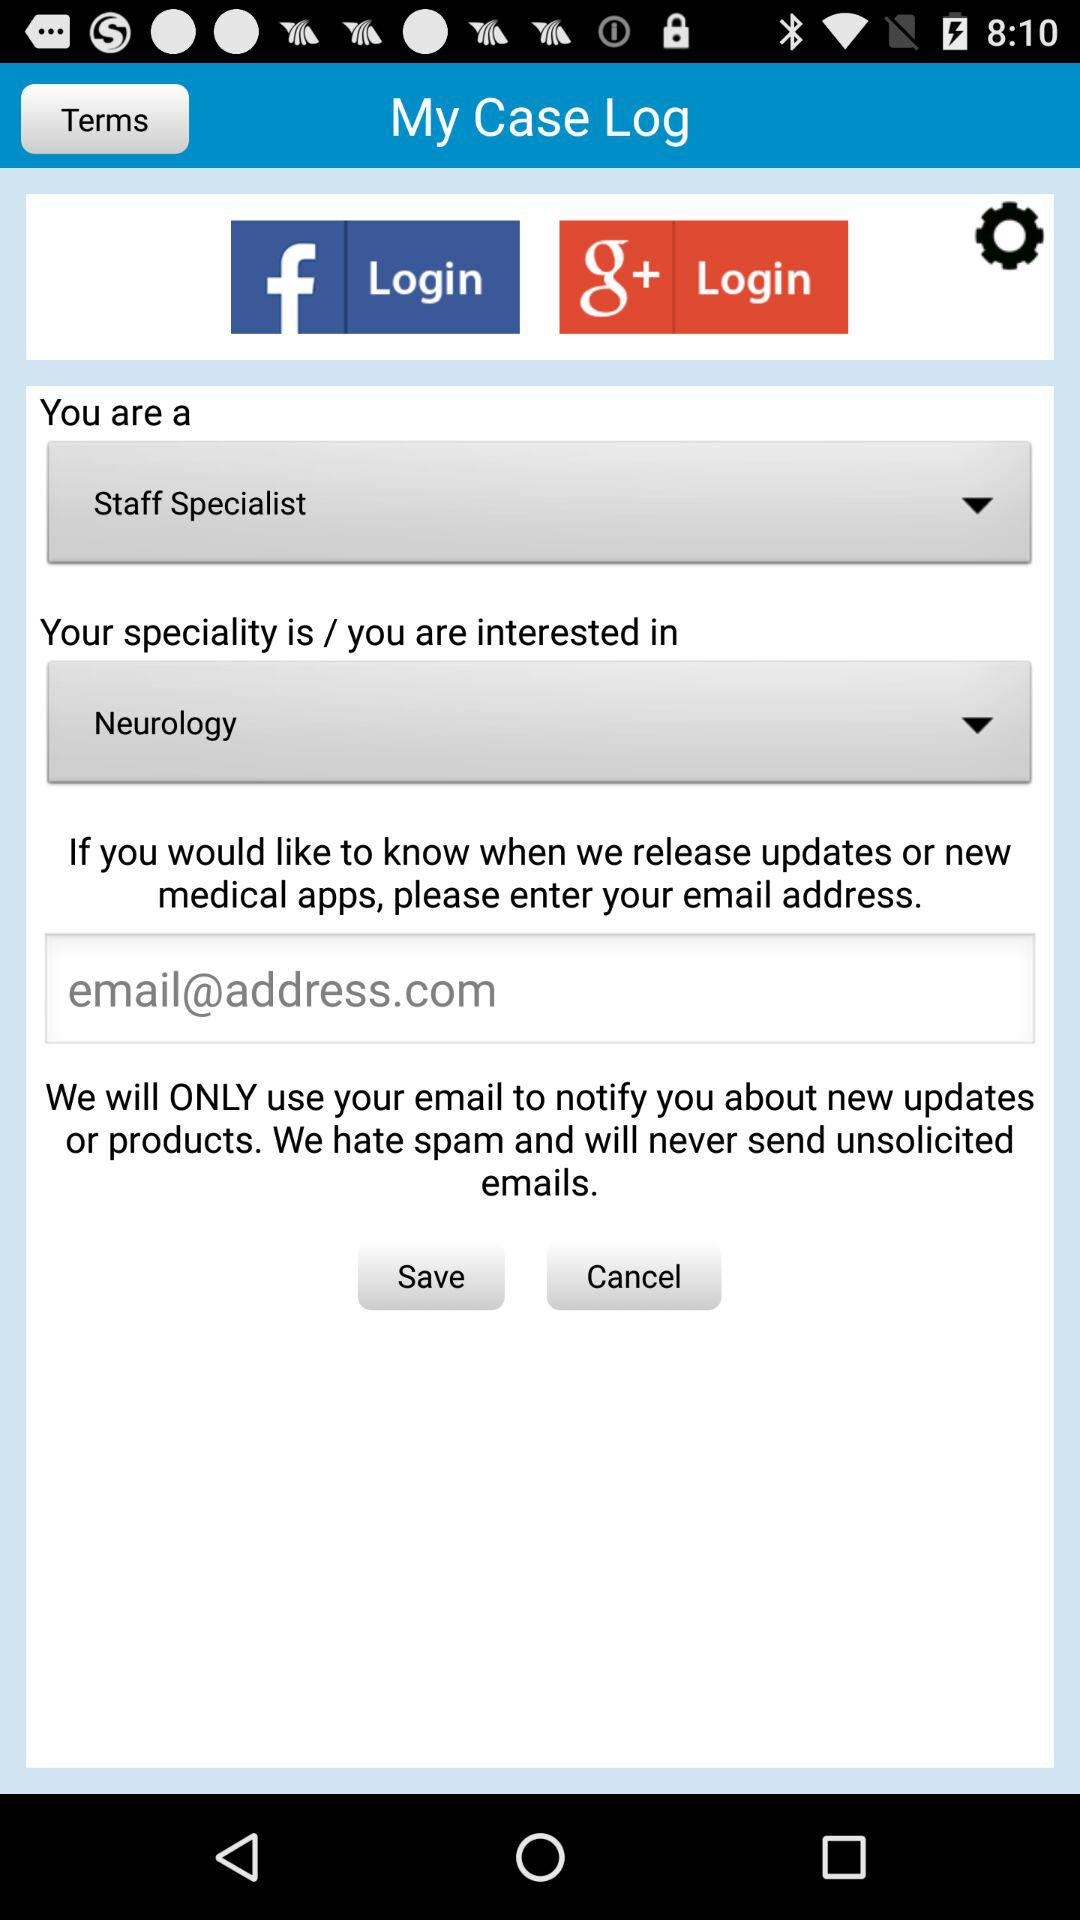What is required to get notification? To get notification, email is required. 